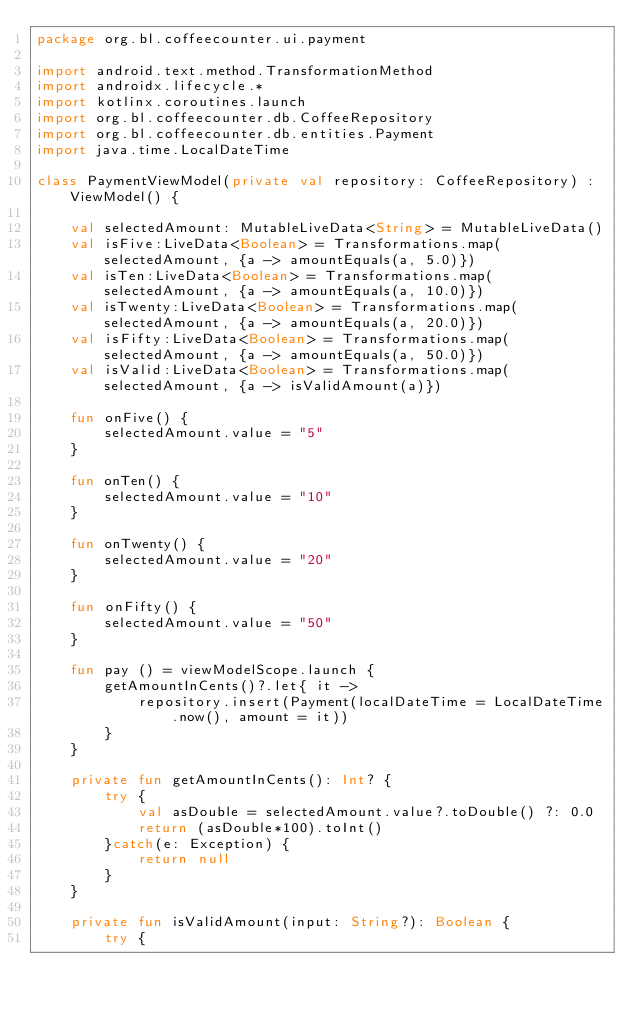Convert code to text. <code><loc_0><loc_0><loc_500><loc_500><_Kotlin_>package org.bl.coffeecounter.ui.payment

import android.text.method.TransformationMethod
import androidx.lifecycle.*
import kotlinx.coroutines.launch
import org.bl.coffeecounter.db.CoffeeRepository
import org.bl.coffeecounter.db.entities.Payment
import java.time.LocalDateTime

class PaymentViewModel(private val repository: CoffeeRepository) : ViewModel() {

    val selectedAmount: MutableLiveData<String> = MutableLiveData()
    val isFive:LiveData<Boolean> = Transformations.map(selectedAmount, {a -> amountEquals(a, 5.0)})
    val isTen:LiveData<Boolean> = Transformations.map(selectedAmount, {a -> amountEquals(a, 10.0)})
    val isTwenty:LiveData<Boolean> = Transformations.map(selectedAmount, {a -> amountEquals(a, 20.0)})
    val isFifty:LiveData<Boolean> = Transformations.map(selectedAmount, {a -> amountEquals(a, 50.0)})
    val isValid:LiveData<Boolean> = Transformations.map(selectedAmount, {a -> isValidAmount(a)})

    fun onFive() {
        selectedAmount.value = "5"
    }

    fun onTen() {
        selectedAmount.value = "10"
    }

    fun onTwenty() {
        selectedAmount.value = "20"
    }

    fun onFifty() {
        selectedAmount.value = "50"
    }

    fun pay () = viewModelScope.launch {
        getAmountInCents()?.let{ it ->
            repository.insert(Payment(localDateTime = LocalDateTime.now(), amount = it))
        }
    }

    private fun getAmountInCents(): Int? {
        try {
            val asDouble = selectedAmount.value?.toDouble() ?: 0.0
            return (asDouble*100).toInt()
        }catch(e: Exception) {
            return null
        }
    }

    private fun isValidAmount(input: String?): Boolean {
        try {</code> 